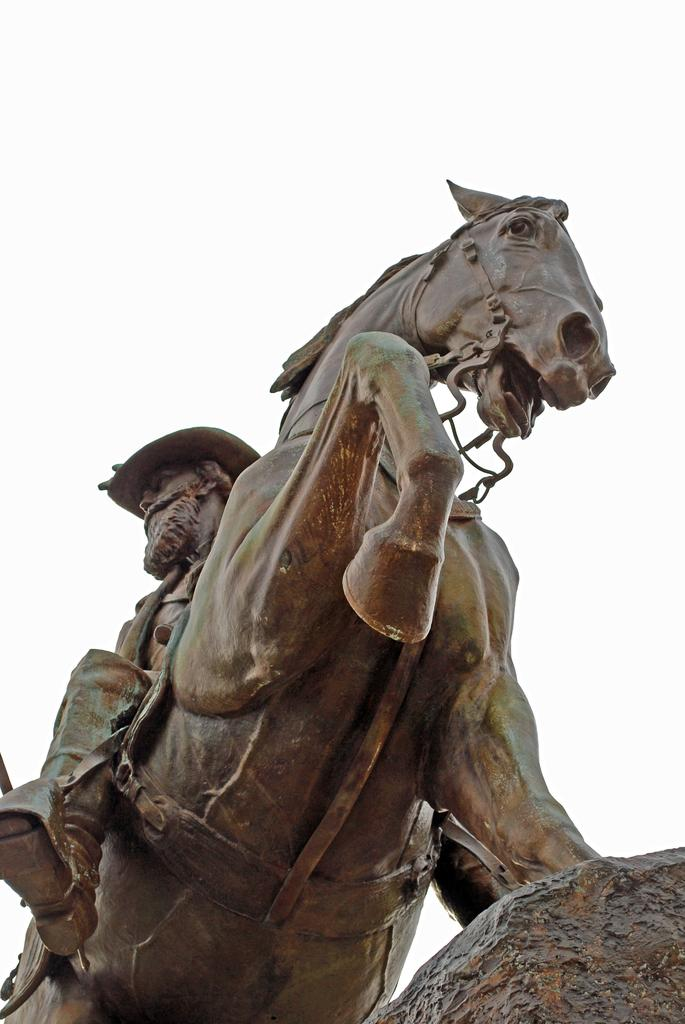What is the main subject in the center of the image? There is a sculpture in the center of the image. What can be seen in the background of the image? There is sky visible in the background of the image. What type of cat is sitting on the plate in the image? There is no cat or plate present in the image; it only features a sculpture and sky in the background. 